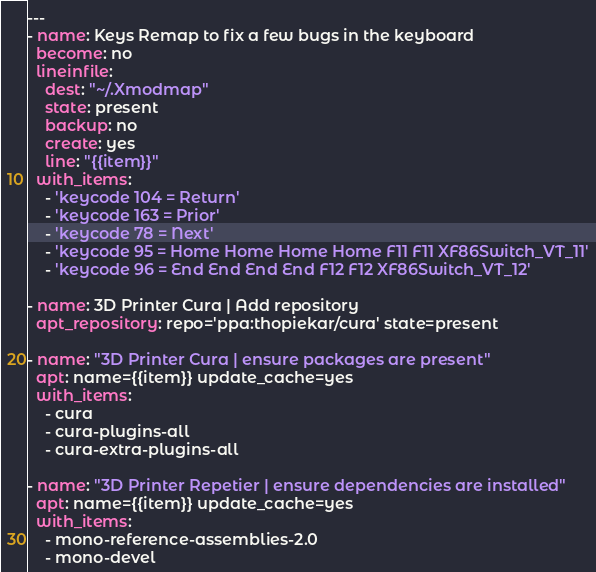Convert code to text. <code><loc_0><loc_0><loc_500><loc_500><_YAML_>---
- name: Keys Remap to fix a few bugs in the keyboard
  become: no
  lineinfile:
    dest: "~/.Xmodmap"
    state: present
    backup: no
    create: yes
    line: "{{item}}"
  with_items:
    - 'keycode 104 = Return'
    - 'keycode 163 = Prior'
    - 'keycode 78 = Next'
    - 'keycode 95 = Home Home Home Home F11 F11 XF86Switch_VT_11'
    - 'keycode 96 = End End End End F12 F12 XF86Switch_VT_12'

- name: 3D Printer Cura | Add repository
  apt_repository: repo='ppa:thopiekar/cura' state=present

- name: "3D Printer Cura | ensure packages are present"
  apt: name={{item}} update_cache=yes
  with_items:
    - cura
    - cura-plugins-all
    - cura-extra-plugins-all

- name: "3D Printer Repetier | ensure dependencies are installed"
  apt: name={{item}} update_cache=yes
  with_items:
    - mono-reference-assemblies-2.0
    - mono-devel
</code> 